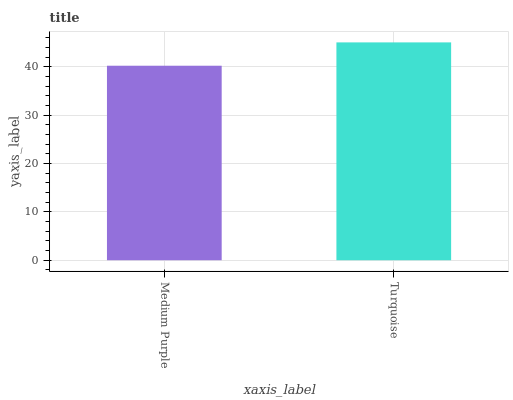Is Medium Purple the minimum?
Answer yes or no. Yes. Is Turquoise the maximum?
Answer yes or no. Yes. Is Turquoise the minimum?
Answer yes or no. No. Is Turquoise greater than Medium Purple?
Answer yes or no. Yes. Is Medium Purple less than Turquoise?
Answer yes or no. Yes. Is Medium Purple greater than Turquoise?
Answer yes or no. No. Is Turquoise less than Medium Purple?
Answer yes or no. No. Is Turquoise the high median?
Answer yes or no. Yes. Is Medium Purple the low median?
Answer yes or no. Yes. Is Medium Purple the high median?
Answer yes or no. No. Is Turquoise the low median?
Answer yes or no. No. 